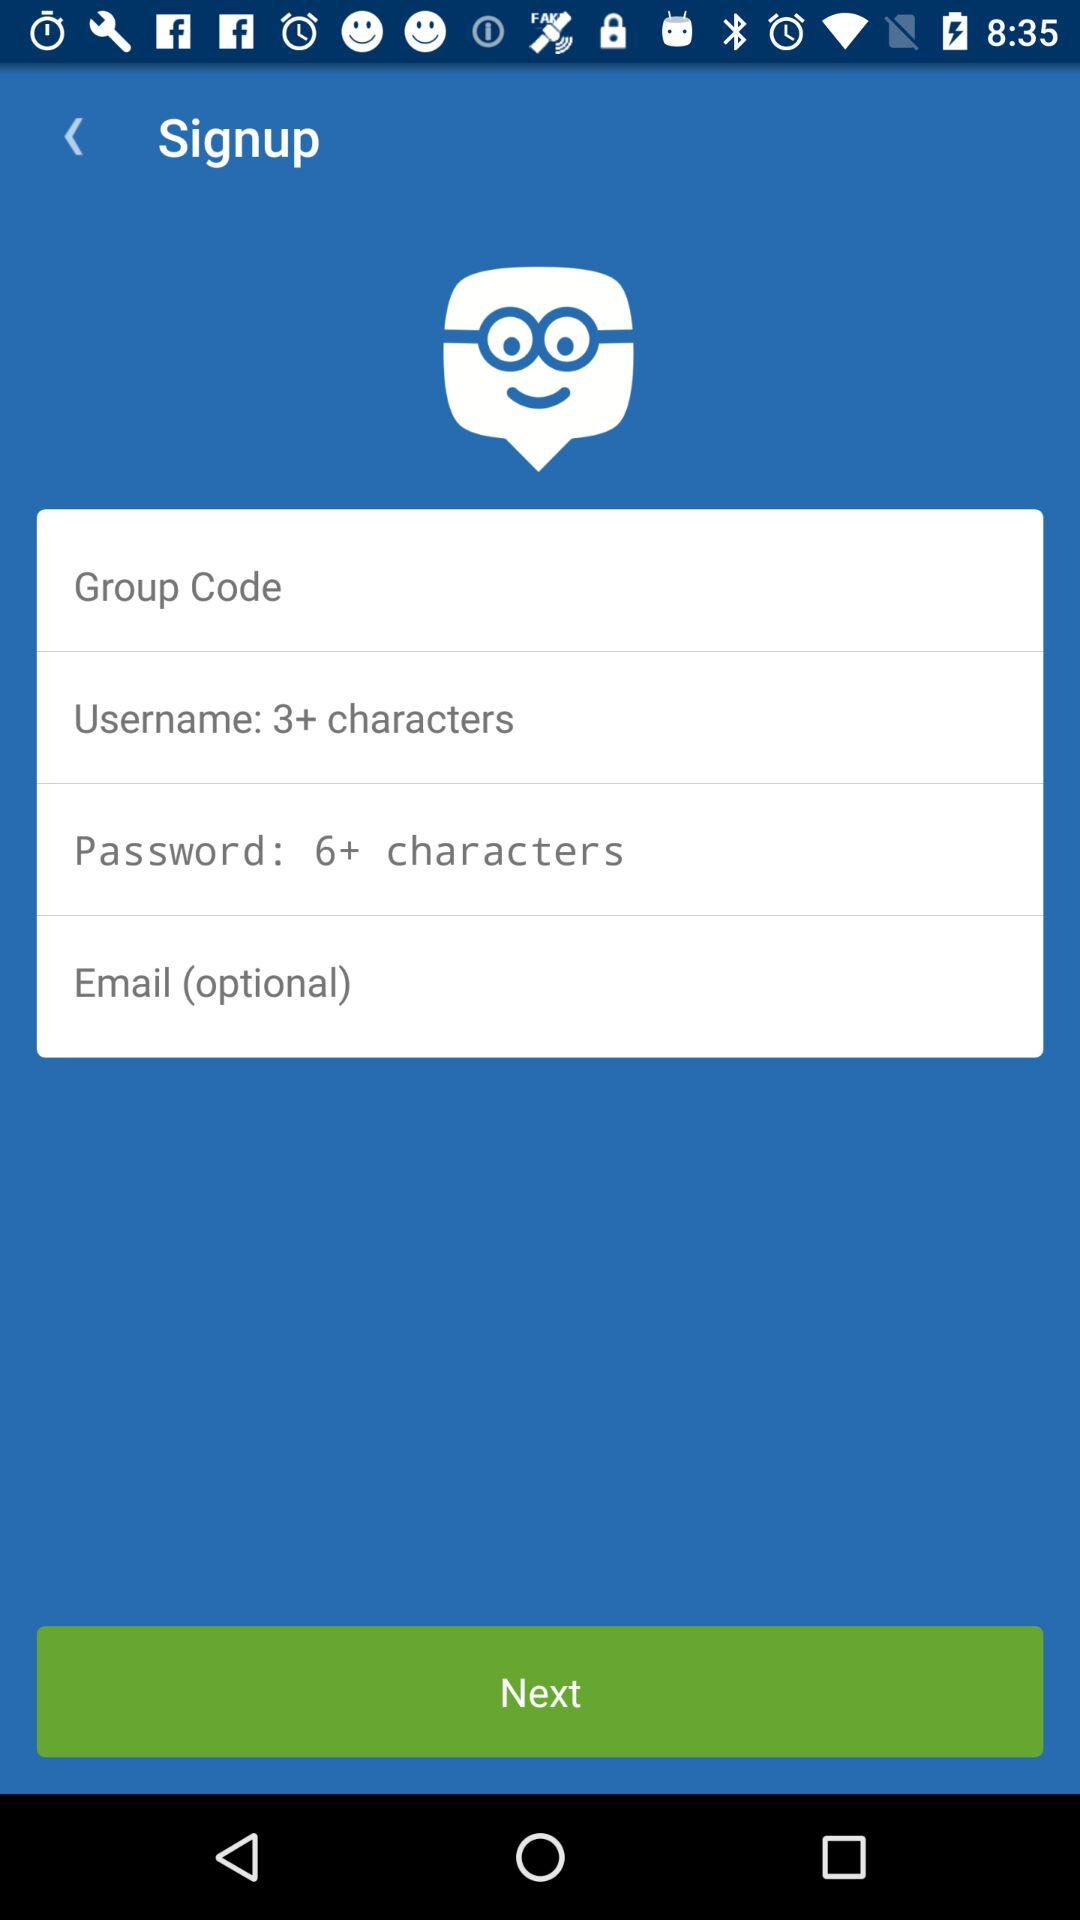How many text inputs are required to sign up?
Answer the question using a single word or phrase. 4 